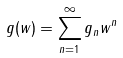Convert formula to latex. <formula><loc_0><loc_0><loc_500><loc_500>g ( w ) = \sum _ { n = 1 } ^ { \infty } g _ { n } w ^ { n }</formula> 